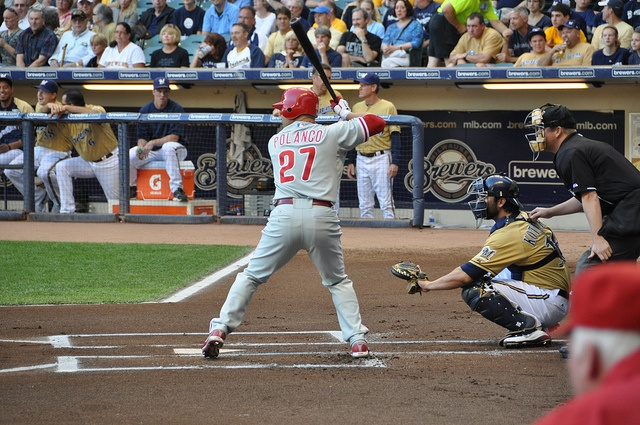Describe the objects in this image and their specific colors. I can see people in black, darkgray, gray, and brown tones, people in black, darkgray, lightgray, gray, and lightblue tones, people in black, gray, tan, and darkgray tones, people in black, gray, and darkgray tones, and people in black, darkgray, olive, and gray tones in this image. 